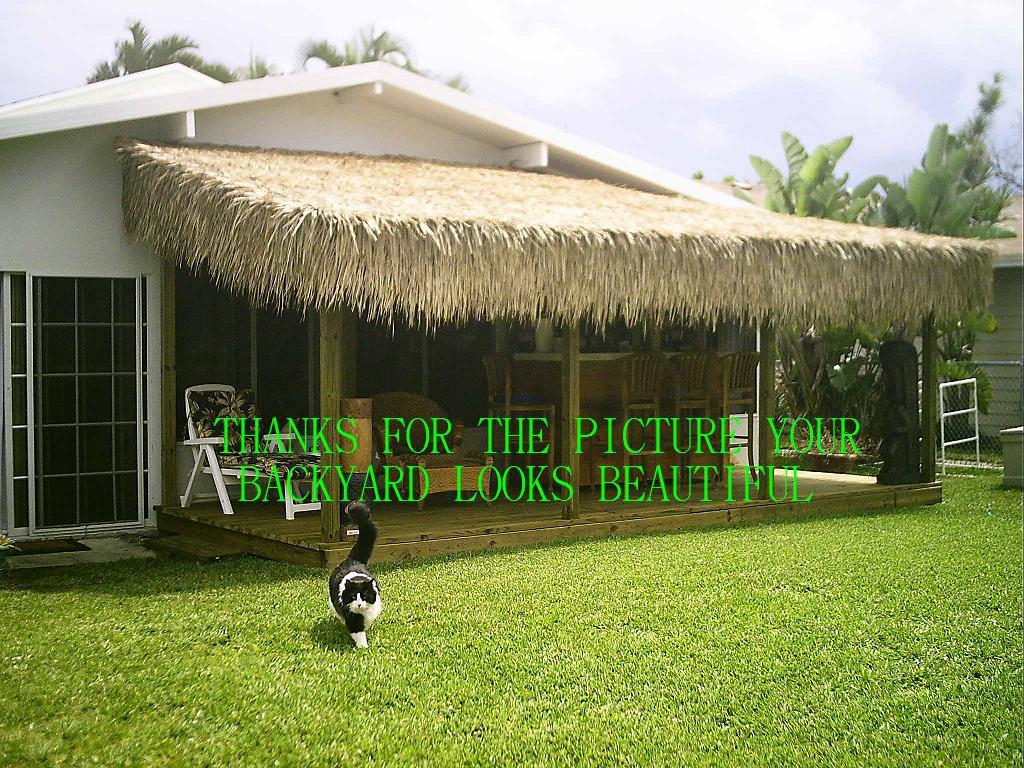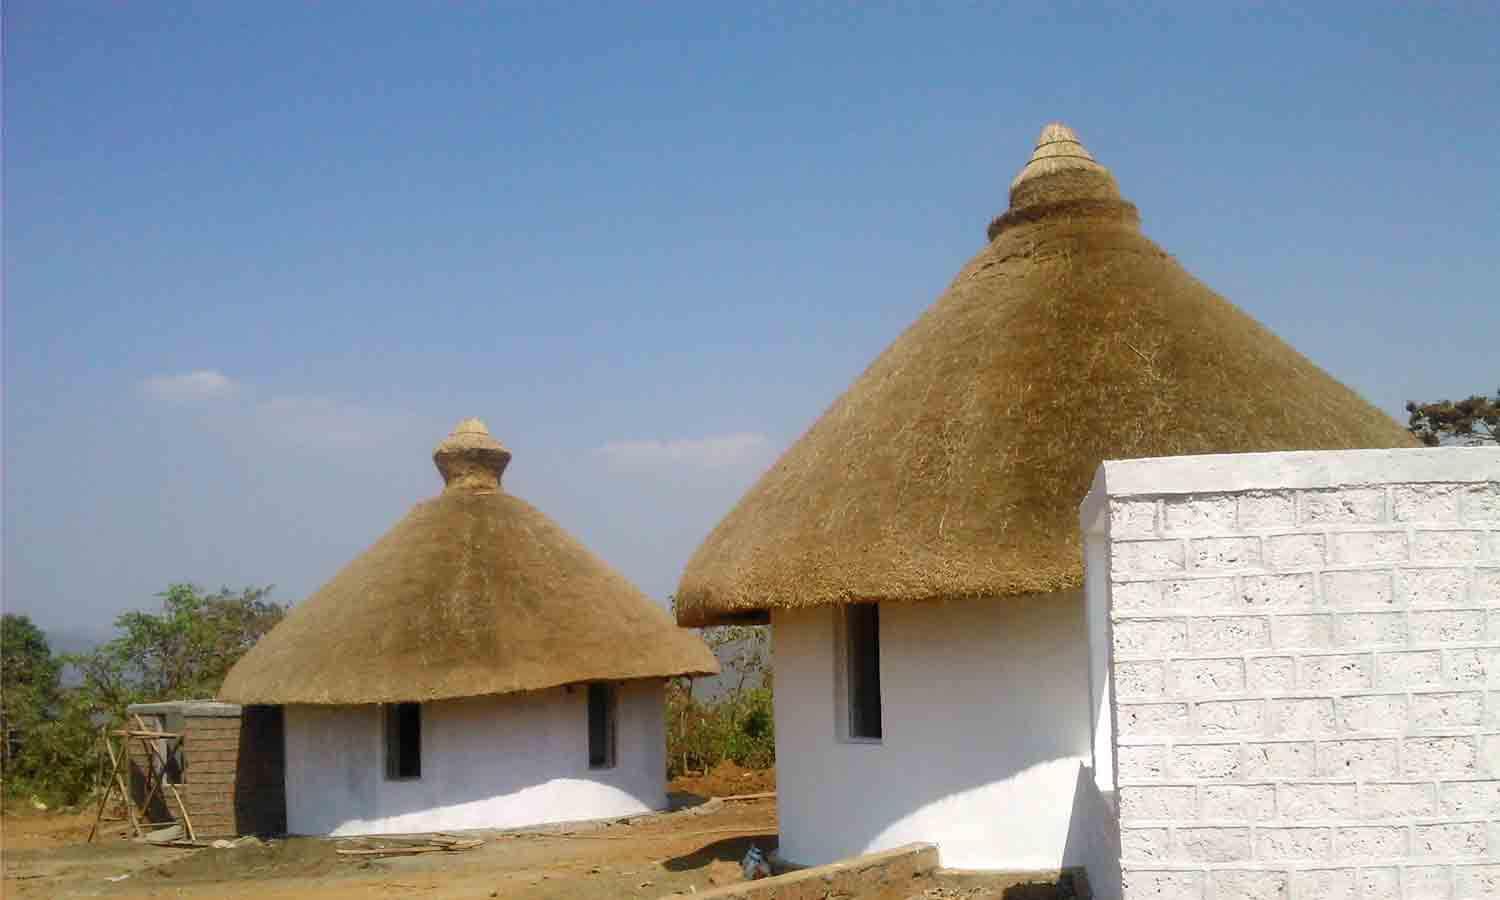The first image is the image on the left, the second image is the image on the right. Evaluate the accuracy of this statement regarding the images: "A round hut with a round grass roof can be seen.". Is it true? Answer yes or no. Yes. The first image is the image on the left, the second image is the image on the right. Evaluate the accuracy of this statement regarding the images: "One image shows a structure with at least one peaked roof held up by beams and with open sides, in front of a body of water". Is it true? Answer yes or no. No. 